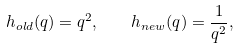<formula> <loc_0><loc_0><loc_500><loc_500>h _ { o l d } ( q ) = q ^ { 2 } , \quad h _ { n e w } ( q ) = \frac { 1 } { q ^ { 2 } } ,</formula> 